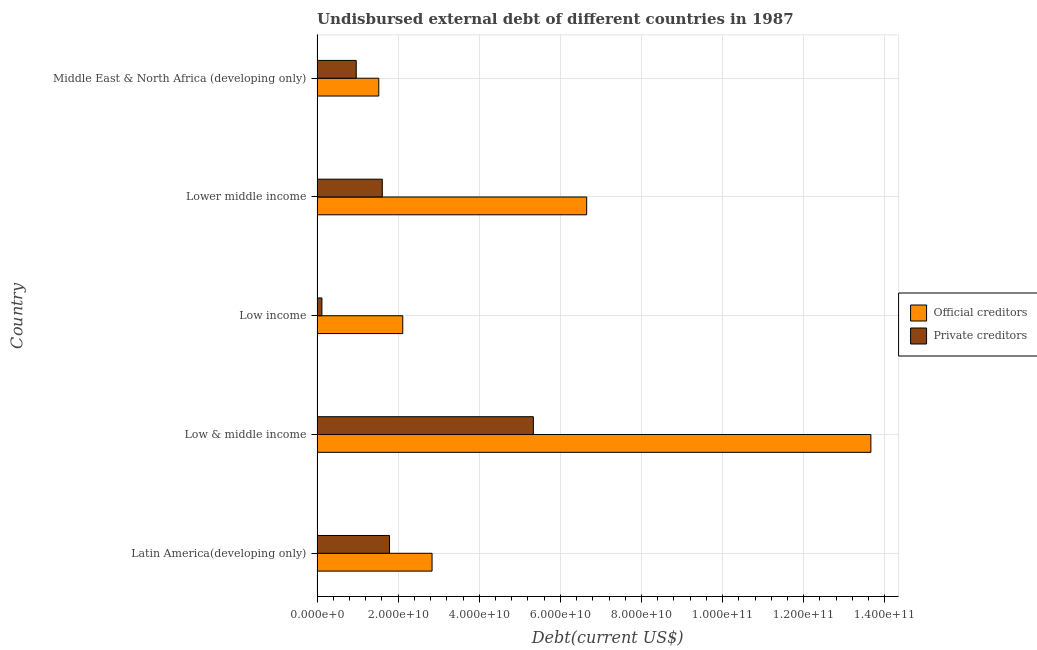How many groups of bars are there?
Ensure brevity in your answer.  5. How many bars are there on the 1st tick from the bottom?
Make the answer very short. 2. What is the label of the 1st group of bars from the top?
Offer a very short reply. Middle East & North Africa (developing only). What is the undisbursed external debt of private creditors in Low & middle income?
Make the answer very short. 5.33e+1. Across all countries, what is the maximum undisbursed external debt of official creditors?
Your answer should be very brief. 1.37e+11. Across all countries, what is the minimum undisbursed external debt of official creditors?
Your response must be concise. 1.52e+1. In which country was the undisbursed external debt of private creditors maximum?
Your answer should be compact. Low & middle income. In which country was the undisbursed external debt of official creditors minimum?
Keep it short and to the point. Middle East & North Africa (developing only). What is the total undisbursed external debt of private creditors in the graph?
Offer a very short reply. 9.82e+1. What is the difference between the undisbursed external debt of private creditors in Latin America(developing only) and that in Low & middle income?
Provide a short and direct response. -3.55e+1. What is the difference between the undisbursed external debt of private creditors in Lower middle income and the undisbursed external debt of official creditors in Low income?
Offer a terse response. -5.05e+09. What is the average undisbursed external debt of official creditors per country?
Your answer should be compact. 5.36e+1. What is the difference between the undisbursed external debt of official creditors and undisbursed external debt of private creditors in Low & middle income?
Ensure brevity in your answer.  8.32e+1. What is the ratio of the undisbursed external debt of official creditors in Low & middle income to that in Low income?
Your answer should be compact. 6.46. Is the undisbursed external debt of private creditors in Latin America(developing only) less than that in Low & middle income?
Give a very brief answer. Yes. Is the difference between the undisbursed external debt of private creditors in Low & middle income and Lower middle income greater than the difference between the undisbursed external debt of official creditors in Low & middle income and Lower middle income?
Provide a succinct answer. No. What is the difference between the highest and the second highest undisbursed external debt of official creditors?
Your answer should be compact. 7.01e+1. What is the difference between the highest and the lowest undisbursed external debt of official creditors?
Keep it short and to the point. 1.21e+11. In how many countries, is the undisbursed external debt of private creditors greater than the average undisbursed external debt of private creditors taken over all countries?
Offer a terse response. 1. What does the 2nd bar from the top in Lower middle income represents?
Provide a succinct answer. Official creditors. What does the 2nd bar from the bottom in Lower middle income represents?
Your answer should be compact. Private creditors. What is the difference between two consecutive major ticks on the X-axis?
Provide a short and direct response. 2.00e+1. Does the graph contain any zero values?
Ensure brevity in your answer.  No. How are the legend labels stacked?
Give a very brief answer. Vertical. What is the title of the graph?
Offer a very short reply. Undisbursed external debt of different countries in 1987. Does "Age 65(female)" appear as one of the legend labels in the graph?
Make the answer very short. No. What is the label or title of the X-axis?
Offer a very short reply. Debt(current US$). What is the Debt(current US$) in Official creditors in Latin America(developing only)?
Your answer should be compact. 2.84e+1. What is the Debt(current US$) in Private creditors in Latin America(developing only)?
Make the answer very short. 1.79e+1. What is the Debt(current US$) in Official creditors in Low & middle income?
Offer a very short reply. 1.37e+11. What is the Debt(current US$) in Private creditors in Low & middle income?
Provide a succinct answer. 5.33e+1. What is the Debt(current US$) of Official creditors in Low income?
Provide a succinct answer. 2.11e+1. What is the Debt(current US$) in Private creditors in Low income?
Give a very brief answer. 1.20e+09. What is the Debt(current US$) of Official creditors in Lower middle income?
Offer a terse response. 6.65e+1. What is the Debt(current US$) of Private creditors in Lower middle income?
Your response must be concise. 1.61e+1. What is the Debt(current US$) in Official creditors in Middle East & North Africa (developing only)?
Your response must be concise. 1.52e+1. What is the Debt(current US$) in Private creditors in Middle East & North Africa (developing only)?
Provide a short and direct response. 9.66e+09. Across all countries, what is the maximum Debt(current US$) in Official creditors?
Your answer should be compact. 1.37e+11. Across all countries, what is the maximum Debt(current US$) in Private creditors?
Your answer should be very brief. 5.33e+1. Across all countries, what is the minimum Debt(current US$) in Official creditors?
Make the answer very short. 1.52e+1. Across all countries, what is the minimum Debt(current US$) in Private creditors?
Offer a very short reply. 1.20e+09. What is the total Debt(current US$) in Official creditors in the graph?
Your answer should be compact. 2.68e+11. What is the total Debt(current US$) in Private creditors in the graph?
Offer a terse response. 9.82e+1. What is the difference between the Debt(current US$) of Official creditors in Latin America(developing only) and that in Low & middle income?
Offer a very short reply. -1.08e+11. What is the difference between the Debt(current US$) in Private creditors in Latin America(developing only) and that in Low & middle income?
Make the answer very short. -3.55e+1. What is the difference between the Debt(current US$) of Official creditors in Latin America(developing only) and that in Low income?
Provide a short and direct response. 7.22e+09. What is the difference between the Debt(current US$) of Private creditors in Latin America(developing only) and that in Low income?
Give a very brief answer. 1.67e+1. What is the difference between the Debt(current US$) in Official creditors in Latin America(developing only) and that in Lower middle income?
Your answer should be compact. -3.81e+1. What is the difference between the Debt(current US$) of Private creditors in Latin America(developing only) and that in Lower middle income?
Make the answer very short. 1.78e+09. What is the difference between the Debt(current US$) of Official creditors in Latin America(developing only) and that in Middle East & North Africa (developing only)?
Your response must be concise. 1.31e+1. What is the difference between the Debt(current US$) in Private creditors in Latin America(developing only) and that in Middle East & North Africa (developing only)?
Give a very brief answer. 8.20e+09. What is the difference between the Debt(current US$) in Official creditors in Low & middle income and that in Low income?
Offer a very short reply. 1.15e+11. What is the difference between the Debt(current US$) of Private creditors in Low & middle income and that in Low income?
Your answer should be compact. 5.21e+1. What is the difference between the Debt(current US$) of Official creditors in Low & middle income and that in Lower middle income?
Offer a very short reply. 7.01e+1. What is the difference between the Debt(current US$) in Private creditors in Low & middle income and that in Lower middle income?
Offer a very short reply. 3.73e+1. What is the difference between the Debt(current US$) in Official creditors in Low & middle income and that in Middle East & North Africa (developing only)?
Your response must be concise. 1.21e+11. What is the difference between the Debt(current US$) in Private creditors in Low & middle income and that in Middle East & North Africa (developing only)?
Your response must be concise. 4.37e+1. What is the difference between the Debt(current US$) of Official creditors in Low income and that in Lower middle income?
Offer a terse response. -4.53e+1. What is the difference between the Debt(current US$) in Private creditors in Low income and that in Lower middle income?
Your answer should be very brief. -1.49e+1. What is the difference between the Debt(current US$) in Official creditors in Low income and that in Middle East & North Africa (developing only)?
Your response must be concise. 5.92e+09. What is the difference between the Debt(current US$) in Private creditors in Low income and that in Middle East & North Africa (developing only)?
Provide a succinct answer. -8.46e+09. What is the difference between the Debt(current US$) of Official creditors in Lower middle income and that in Middle East & North Africa (developing only)?
Ensure brevity in your answer.  5.13e+1. What is the difference between the Debt(current US$) of Private creditors in Lower middle income and that in Middle East & North Africa (developing only)?
Provide a short and direct response. 6.42e+09. What is the difference between the Debt(current US$) of Official creditors in Latin America(developing only) and the Debt(current US$) of Private creditors in Low & middle income?
Your answer should be compact. -2.50e+1. What is the difference between the Debt(current US$) in Official creditors in Latin America(developing only) and the Debt(current US$) in Private creditors in Low income?
Provide a short and direct response. 2.72e+1. What is the difference between the Debt(current US$) in Official creditors in Latin America(developing only) and the Debt(current US$) in Private creditors in Lower middle income?
Your answer should be compact. 1.23e+1. What is the difference between the Debt(current US$) in Official creditors in Latin America(developing only) and the Debt(current US$) in Private creditors in Middle East & North Africa (developing only)?
Make the answer very short. 1.87e+1. What is the difference between the Debt(current US$) in Official creditors in Low & middle income and the Debt(current US$) in Private creditors in Low income?
Give a very brief answer. 1.35e+11. What is the difference between the Debt(current US$) in Official creditors in Low & middle income and the Debt(current US$) in Private creditors in Lower middle income?
Keep it short and to the point. 1.20e+11. What is the difference between the Debt(current US$) of Official creditors in Low & middle income and the Debt(current US$) of Private creditors in Middle East & North Africa (developing only)?
Your response must be concise. 1.27e+11. What is the difference between the Debt(current US$) of Official creditors in Low income and the Debt(current US$) of Private creditors in Lower middle income?
Make the answer very short. 5.05e+09. What is the difference between the Debt(current US$) in Official creditors in Low income and the Debt(current US$) in Private creditors in Middle East & North Africa (developing only)?
Keep it short and to the point. 1.15e+1. What is the difference between the Debt(current US$) of Official creditors in Lower middle income and the Debt(current US$) of Private creditors in Middle East & North Africa (developing only)?
Offer a very short reply. 5.68e+1. What is the average Debt(current US$) of Official creditors per country?
Make the answer very short. 5.36e+1. What is the average Debt(current US$) in Private creditors per country?
Provide a short and direct response. 1.96e+1. What is the difference between the Debt(current US$) of Official creditors and Debt(current US$) of Private creditors in Latin America(developing only)?
Your answer should be compact. 1.05e+1. What is the difference between the Debt(current US$) of Official creditors and Debt(current US$) of Private creditors in Low & middle income?
Your response must be concise. 8.32e+1. What is the difference between the Debt(current US$) in Official creditors and Debt(current US$) in Private creditors in Low income?
Give a very brief answer. 1.99e+1. What is the difference between the Debt(current US$) in Official creditors and Debt(current US$) in Private creditors in Lower middle income?
Keep it short and to the point. 5.04e+1. What is the difference between the Debt(current US$) in Official creditors and Debt(current US$) in Private creditors in Middle East & North Africa (developing only)?
Provide a short and direct response. 5.56e+09. What is the ratio of the Debt(current US$) in Official creditors in Latin America(developing only) to that in Low & middle income?
Provide a short and direct response. 0.21. What is the ratio of the Debt(current US$) of Private creditors in Latin America(developing only) to that in Low & middle income?
Offer a terse response. 0.34. What is the ratio of the Debt(current US$) of Official creditors in Latin America(developing only) to that in Low income?
Ensure brevity in your answer.  1.34. What is the ratio of the Debt(current US$) of Private creditors in Latin America(developing only) to that in Low income?
Offer a terse response. 14.91. What is the ratio of the Debt(current US$) in Official creditors in Latin America(developing only) to that in Lower middle income?
Keep it short and to the point. 0.43. What is the ratio of the Debt(current US$) of Private creditors in Latin America(developing only) to that in Lower middle income?
Offer a terse response. 1.11. What is the ratio of the Debt(current US$) in Official creditors in Latin America(developing only) to that in Middle East & North Africa (developing only)?
Your answer should be very brief. 1.86. What is the ratio of the Debt(current US$) of Private creditors in Latin America(developing only) to that in Middle East & North Africa (developing only)?
Ensure brevity in your answer.  1.85. What is the ratio of the Debt(current US$) of Official creditors in Low & middle income to that in Low income?
Make the answer very short. 6.46. What is the ratio of the Debt(current US$) in Private creditors in Low & middle income to that in Low income?
Make the answer very short. 44.5. What is the ratio of the Debt(current US$) of Official creditors in Low & middle income to that in Lower middle income?
Offer a very short reply. 2.05. What is the ratio of the Debt(current US$) of Private creditors in Low & middle income to that in Lower middle income?
Make the answer very short. 3.32. What is the ratio of the Debt(current US$) in Official creditors in Low & middle income to that in Middle East & North Africa (developing only)?
Provide a short and direct response. 8.97. What is the ratio of the Debt(current US$) of Private creditors in Low & middle income to that in Middle East & North Africa (developing only)?
Your answer should be compact. 5.52. What is the ratio of the Debt(current US$) in Official creditors in Low income to that in Lower middle income?
Your answer should be very brief. 0.32. What is the ratio of the Debt(current US$) in Private creditors in Low income to that in Lower middle income?
Make the answer very short. 0.07. What is the ratio of the Debt(current US$) in Official creditors in Low income to that in Middle East & North Africa (developing only)?
Ensure brevity in your answer.  1.39. What is the ratio of the Debt(current US$) of Private creditors in Low income to that in Middle East & North Africa (developing only)?
Ensure brevity in your answer.  0.12. What is the ratio of the Debt(current US$) of Official creditors in Lower middle income to that in Middle East & North Africa (developing only)?
Offer a terse response. 4.37. What is the ratio of the Debt(current US$) of Private creditors in Lower middle income to that in Middle East & North Africa (developing only)?
Give a very brief answer. 1.66. What is the difference between the highest and the second highest Debt(current US$) of Official creditors?
Your answer should be compact. 7.01e+1. What is the difference between the highest and the second highest Debt(current US$) of Private creditors?
Keep it short and to the point. 3.55e+1. What is the difference between the highest and the lowest Debt(current US$) in Official creditors?
Your answer should be compact. 1.21e+11. What is the difference between the highest and the lowest Debt(current US$) in Private creditors?
Your response must be concise. 5.21e+1. 